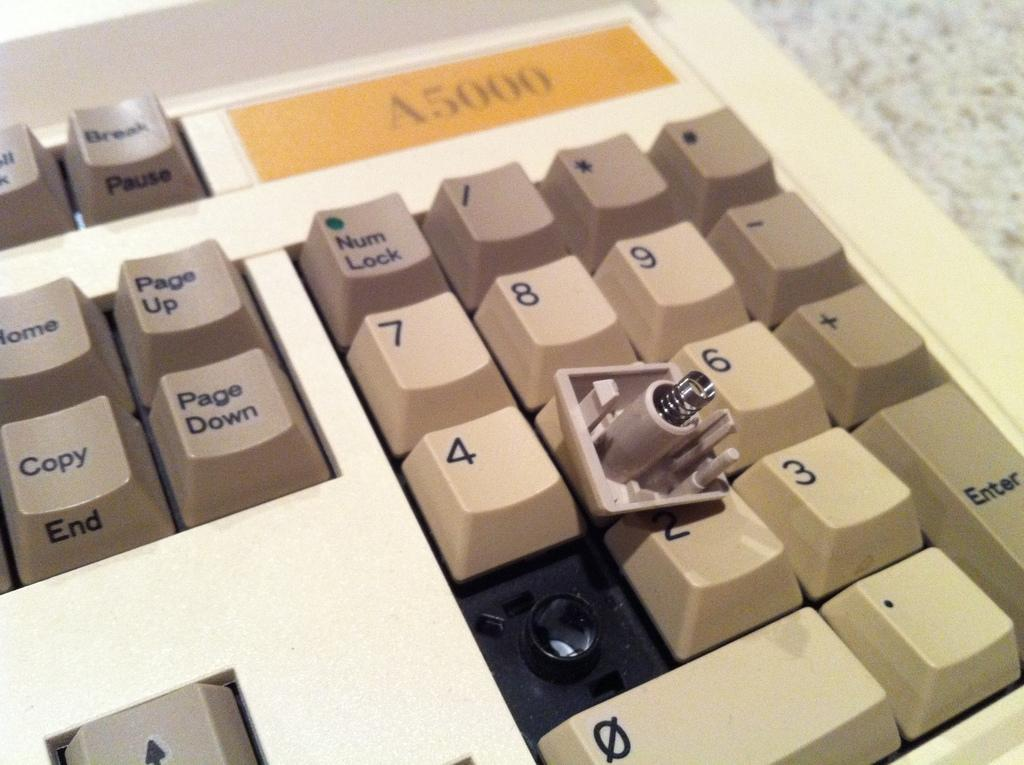<image>
Create a compact narrative representing the image presented. a keyboard with a label on the top of 'a5000' 